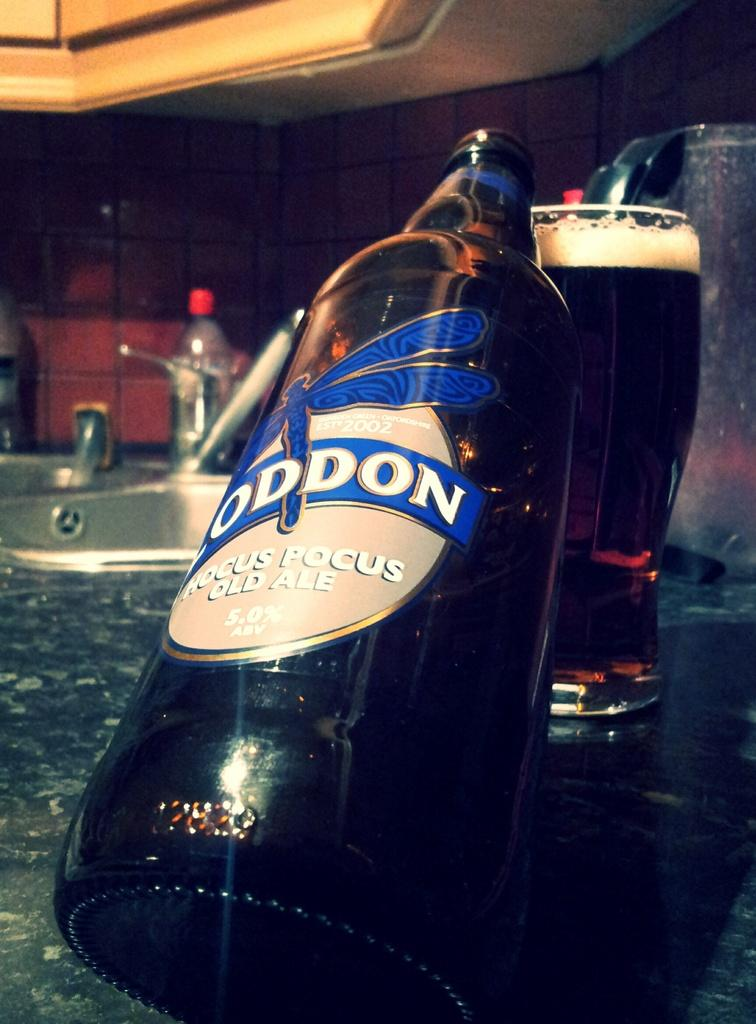What object can be seen in the image that is typically used for holding liquids? There is a bottle in the image that is typically used for holding liquids. Where is the bottle placed in the image? The bottle is placed on a glass in the image. What is present at the right side of the image? There is a glass at the right side of the image. What is inside the glass? The glass contains a drink. What type of door can be seen in the image? There is no door present in the image. What scale is used to measure the size of the bottle in the image? There is no scale present in the image to measure the size of the bottle. 